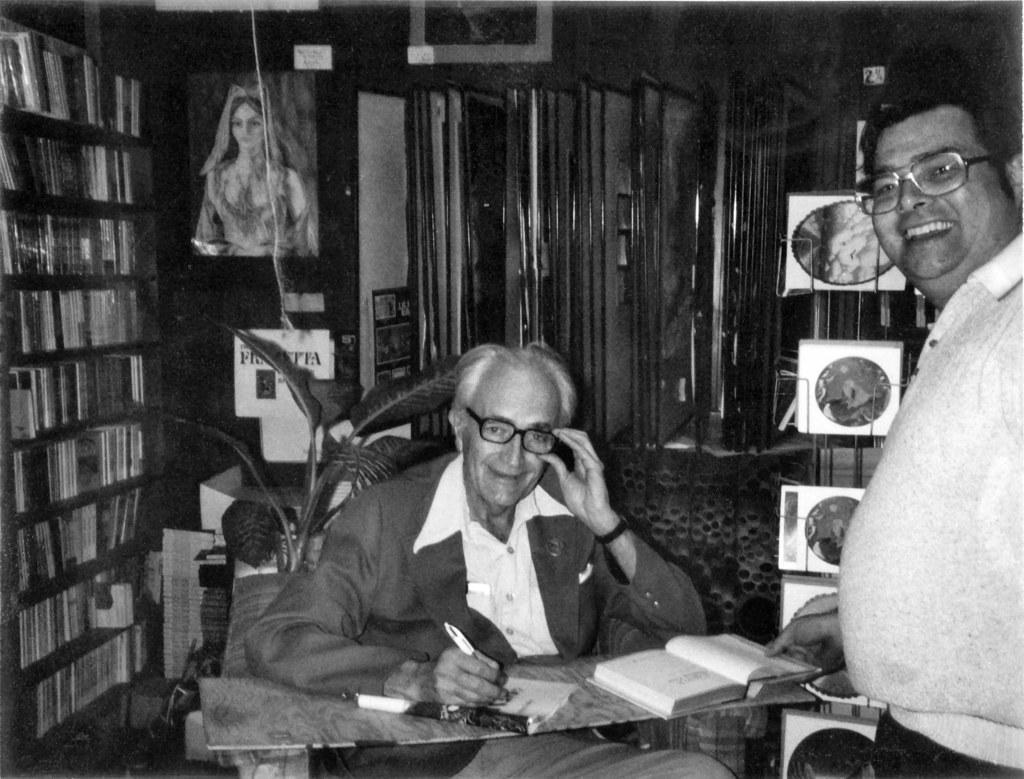Can you describe this image briefly? This is a black and white image. On the right side there is a man standing. In the middle there is another man sitting on the chair in front of the table and holding a pen in the hand. On the table there are two books. There two men are smiling and giving pose for the picture. On the left side there is a rack which is filled with the books. In the background there are few boxes and other objects. At the top there is a frame attached to the wall. 